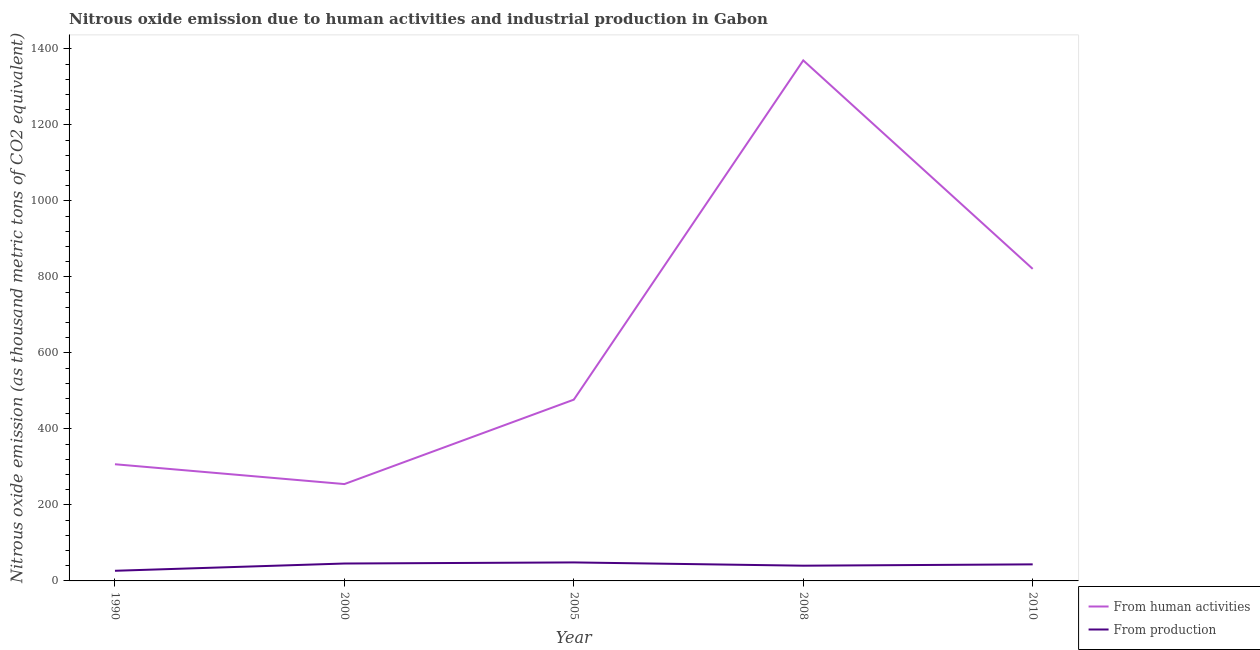How many different coloured lines are there?
Your answer should be compact. 2. Does the line corresponding to amount of emissions generated from industries intersect with the line corresponding to amount of emissions from human activities?
Provide a succinct answer. No. What is the amount of emissions from human activities in 2000?
Offer a very short reply. 254.9. Across all years, what is the maximum amount of emissions generated from industries?
Your answer should be very brief. 48.7. Across all years, what is the minimum amount of emissions generated from industries?
Your answer should be compact. 26.7. In which year was the amount of emissions generated from industries maximum?
Ensure brevity in your answer.  2005. What is the total amount of emissions generated from industries in the graph?
Offer a very short reply. 204.9. What is the difference between the amount of emissions generated from industries in 2005 and that in 2008?
Your answer should be very brief. 8.6. What is the difference between the amount of emissions from human activities in 2005 and the amount of emissions generated from industries in 1990?
Ensure brevity in your answer.  450.4. What is the average amount of emissions from human activities per year?
Ensure brevity in your answer.  646.08. In the year 2000, what is the difference between the amount of emissions from human activities and amount of emissions generated from industries?
Provide a short and direct response. 209.1. What is the ratio of the amount of emissions generated from industries in 2005 to that in 2010?
Make the answer very short. 1.12. What is the difference between the highest and the second highest amount of emissions from human activities?
Keep it short and to the point. 548.7. What is the difference between the highest and the lowest amount of emissions generated from industries?
Your answer should be very brief. 22. Does the amount of emissions generated from industries monotonically increase over the years?
Ensure brevity in your answer.  No. How many lines are there?
Offer a terse response. 2. What is the difference between two consecutive major ticks on the Y-axis?
Keep it short and to the point. 200. How many legend labels are there?
Your answer should be very brief. 2. How are the legend labels stacked?
Your answer should be compact. Vertical. What is the title of the graph?
Ensure brevity in your answer.  Nitrous oxide emission due to human activities and industrial production in Gabon. What is the label or title of the Y-axis?
Provide a succinct answer. Nitrous oxide emission (as thousand metric tons of CO2 equivalent). What is the Nitrous oxide emission (as thousand metric tons of CO2 equivalent) in From human activities in 1990?
Your answer should be very brief. 307.1. What is the Nitrous oxide emission (as thousand metric tons of CO2 equivalent) in From production in 1990?
Your response must be concise. 26.7. What is the Nitrous oxide emission (as thousand metric tons of CO2 equivalent) of From human activities in 2000?
Offer a very short reply. 254.9. What is the Nitrous oxide emission (as thousand metric tons of CO2 equivalent) in From production in 2000?
Offer a very short reply. 45.8. What is the Nitrous oxide emission (as thousand metric tons of CO2 equivalent) in From human activities in 2005?
Provide a short and direct response. 477.1. What is the Nitrous oxide emission (as thousand metric tons of CO2 equivalent) of From production in 2005?
Your response must be concise. 48.7. What is the Nitrous oxide emission (as thousand metric tons of CO2 equivalent) of From human activities in 2008?
Keep it short and to the point. 1370. What is the Nitrous oxide emission (as thousand metric tons of CO2 equivalent) in From production in 2008?
Keep it short and to the point. 40.1. What is the Nitrous oxide emission (as thousand metric tons of CO2 equivalent) of From human activities in 2010?
Your answer should be very brief. 821.3. What is the Nitrous oxide emission (as thousand metric tons of CO2 equivalent) of From production in 2010?
Your answer should be very brief. 43.6. Across all years, what is the maximum Nitrous oxide emission (as thousand metric tons of CO2 equivalent) in From human activities?
Provide a succinct answer. 1370. Across all years, what is the maximum Nitrous oxide emission (as thousand metric tons of CO2 equivalent) of From production?
Provide a succinct answer. 48.7. Across all years, what is the minimum Nitrous oxide emission (as thousand metric tons of CO2 equivalent) in From human activities?
Keep it short and to the point. 254.9. Across all years, what is the minimum Nitrous oxide emission (as thousand metric tons of CO2 equivalent) of From production?
Ensure brevity in your answer.  26.7. What is the total Nitrous oxide emission (as thousand metric tons of CO2 equivalent) in From human activities in the graph?
Make the answer very short. 3230.4. What is the total Nitrous oxide emission (as thousand metric tons of CO2 equivalent) in From production in the graph?
Offer a very short reply. 204.9. What is the difference between the Nitrous oxide emission (as thousand metric tons of CO2 equivalent) in From human activities in 1990 and that in 2000?
Provide a short and direct response. 52.2. What is the difference between the Nitrous oxide emission (as thousand metric tons of CO2 equivalent) in From production in 1990 and that in 2000?
Offer a very short reply. -19.1. What is the difference between the Nitrous oxide emission (as thousand metric tons of CO2 equivalent) of From human activities in 1990 and that in 2005?
Your response must be concise. -170. What is the difference between the Nitrous oxide emission (as thousand metric tons of CO2 equivalent) of From human activities in 1990 and that in 2008?
Keep it short and to the point. -1062.9. What is the difference between the Nitrous oxide emission (as thousand metric tons of CO2 equivalent) in From human activities in 1990 and that in 2010?
Keep it short and to the point. -514.2. What is the difference between the Nitrous oxide emission (as thousand metric tons of CO2 equivalent) in From production in 1990 and that in 2010?
Keep it short and to the point. -16.9. What is the difference between the Nitrous oxide emission (as thousand metric tons of CO2 equivalent) of From human activities in 2000 and that in 2005?
Offer a very short reply. -222.2. What is the difference between the Nitrous oxide emission (as thousand metric tons of CO2 equivalent) of From production in 2000 and that in 2005?
Keep it short and to the point. -2.9. What is the difference between the Nitrous oxide emission (as thousand metric tons of CO2 equivalent) of From human activities in 2000 and that in 2008?
Offer a terse response. -1115.1. What is the difference between the Nitrous oxide emission (as thousand metric tons of CO2 equivalent) of From human activities in 2000 and that in 2010?
Ensure brevity in your answer.  -566.4. What is the difference between the Nitrous oxide emission (as thousand metric tons of CO2 equivalent) of From human activities in 2005 and that in 2008?
Keep it short and to the point. -892.9. What is the difference between the Nitrous oxide emission (as thousand metric tons of CO2 equivalent) of From production in 2005 and that in 2008?
Provide a succinct answer. 8.6. What is the difference between the Nitrous oxide emission (as thousand metric tons of CO2 equivalent) in From human activities in 2005 and that in 2010?
Keep it short and to the point. -344.2. What is the difference between the Nitrous oxide emission (as thousand metric tons of CO2 equivalent) in From production in 2005 and that in 2010?
Give a very brief answer. 5.1. What is the difference between the Nitrous oxide emission (as thousand metric tons of CO2 equivalent) in From human activities in 2008 and that in 2010?
Provide a short and direct response. 548.7. What is the difference between the Nitrous oxide emission (as thousand metric tons of CO2 equivalent) in From human activities in 1990 and the Nitrous oxide emission (as thousand metric tons of CO2 equivalent) in From production in 2000?
Provide a succinct answer. 261.3. What is the difference between the Nitrous oxide emission (as thousand metric tons of CO2 equivalent) in From human activities in 1990 and the Nitrous oxide emission (as thousand metric tons of CO2 equivalent) in From production in 2005?
Provide a short and direct response. 258.4. What is the difference between the Nitrous oxide emission (as thousand metric tons of CO2 equivalent) of From human activities in 1990 and the Nitrous oxide emission (as thousand metric tons of CO2 equivalent) of From production in 2008?
Provide a short and direct response. 267. What is the difference between the Nitrous oxide emission (as thousand metric tons of CO2 equivalent) of From human activities in 1990 and the Nitrous oxide emission (as thousand metric tons of CO2 equivalent) of From production in 2010?
Give a very brief answer. 263.5. What is the difference between the Nitrous oxide emission (as thousand metric tons of CO2 equivalent) of From human activities in 2000 and the Nitrous oxide emission (as thousand metric tons of CO2 equivalent) of From production in 2005?
Offer a very short reply. 206.2. What is the difference between the Nitrous oxide emission (as thousand metric tons of CO2 equivalent) in From human activities in 2000 and the Nitrous oxide emission (as thousand metric tons of CO2 equivalent) in From production in 2008?
Your answer should be very brief. 214.8. What is the difference between the Nitrous oxide emission (as thousand metric tons of CO2 equivalent) in From human activities in 2000 and the Nitrous oxide emission (as thousand metric tons of CO2 equivalent) in From production in 2010?
Keep it short and to the point. 211.3. What is the difference between the Nitrous oxide emission (as thousand metric tons of CO2 equivalent) in From human activities in 2005 and the Nitrous oxide emission (as thousand metric tons of CO2 equivalent) in From production in 2008?
Keep it short and to the point. 437. What is the difference between the Nitrous oxide emission (as thousand metric tons of CO2 equivalent) of From human activities in 2005 and the Nitrous oxide emission (as thousand metric tons of CO2 equivalent) of From production in 2010?
Make the answer very short. 433.5. What is the difference between the Nitrous oxide emission (as thousand metric tons of CO2 equivalent) in From human activities in 2008 and the Nitrous oxide emission (as thousand metric tons of CO2 equivalent) in From production in 2010?
Make the answer very short. 1326.4. What is the average Nitrous oxide emission (as thousand metric tons of CO2 equivalent) of From human activities per year?
Your answer should be compact. 646.08. What is the average Nitrous oxide emission (as thousand metric tons of CO2 equivalent) in From production per year?
Provide a succinct answer. 40.98. In the year 1990, what is the difference between the Nitrous oxide emission (as thousand metric tons of CO2 equivalent) of From human activities and Nitrous oxide emission (as thousand metric tons of CO2 equivalent) of From production?
Offer a terse response. 280.4. In the year 2000, what is the difference between the Nitrous oxide emission (as thousand metric tons of CO2 equivalent) in From human activities and Nitrous oxide emission (as thousand metric tons of CO2 equivalent) in From production?
Offer a terse response. 209.1. In the year 2005, what is the difference between the Nitrous oxide emission (as thousand metric tons of CO2 equivalent) of From human activities and Nitrous oxide emission (as thousand metric tons of CO2 equivalent) of From production?
Your answer should be very brief. 428.4. In the year 2008, what is the difference between the Nitrous oxide emission (as thousand metric tons of CO2 equivalent) in From human activities and Nitrous oxide emission (as thousand metric tons of CO2 equivalent) in From production?
Offer a very short reply. 1329.9. In the year 2010, what is the difference between the Nitrous oxide emission (as thousand metric tons of CO2 equivalent) of From human activities and Nitrous oxide emission (as thousand metric tons of CO2 equivalent) of From production?
Keep it short and to the point. 777.7. What is the ratio of the Nitrous oxide emission (as thousand metric tons of CO2 equivalent) in From human activities in 1990 to that in 2000?
Provide a short and direct response. 1.2. What is the ratio of the Nitrous oxide emission (as thousand metric tons of CO2 equivalent) in From production in 1990 to that in 2000?
Offer a terse response. 0.58. What is the ratio of the Nitrous oxide emission (as thousand metric tons of CO2 equivalent) in From human activities in 1990 to that in 2005?
Provide a short and direct response. 0.64. What is the ratio of the Nitrous oxide emission (as thousand metric tons of CO2 equivalent) in From production in 1990 to that in 2005?
Your response must be concise. 0.55. What is the ratio of the Nitrous oxide emission (as thousand metric tons of CO2 equivalent) of From human activities in 1990 to that in 2008?
Offer a terse response. 0.22. What is the ratio of the Nitrous oxide emission (as thousand metric tons of CO2 equivalent) in From production in 1990 to that in 2008?
Ensure brevity in your answer.  0.67. What is the ratio of the Nitrous oxide emission (as thousand metric tons of CO2 equivalent) of From human activities in 1990 to that in 2010?
Make the answer very short. 0.37. What is the ratio of the Nitrous oxide emission (as thousand metric tons of CO2 equivalent) in From production in 1990 to that in 2010?
Make the answer very short. 0.61. What is the ratio of the Nitrous oxide emission (as thousand metric tons of CO2 equivalent) in From human activities in 2000 to that in 2005?
Provide a short and direct response. 0.53. What is the ratio of the Nitrous oxide emission (as thousand metric tons of CO2 equivalent) of From production in 2000 to that in 2005?
Ensure brevity in your answer.  0.94. What is the ratio of the Nitrous oxide emission (as thousand metric tons of CO2 equivalent) of From human activities in 2000 to that in 2008?
Provide a succinct answer. 0.19. What is the ratio of the Nitrous oxide emission (as thousand metric tons of CO2 equivalent) in From production in 2000 to that in 2008?
Offer a very short reply. 1.14. What is the ratio of the Nitrous oxide emission (as thousand metric tons of CO2 equivalent) in From human activities in 2000 to that in 2010?
Your answer should be very brief. 0.31. What is the ratio of the Nitrous oxide emission (as thousand metric tons of CO2 equivalent) of From production in 2000 to that in 2010?
Your answer should be compact. 1.05. What is the ratio of the Nitrous oxide emission (as thousand metric tons of CO2 equivalent) in From human activities in 2005 to that in 2008?
Make the answer very short. 0.35. What is the ratio of the Nitrous oxide emission (as thousand metric tons of CO2 equivalent) of From production in 2005 to that in 2008?
Keep it short and to the point. 1.21. What is the ratio of the Nitrous oxide emission (as thousand metric tons of CO2 equivalent) in From human activities in 2005 to that in 2010?
Offer a terse response. 0.58. What is the ratio of the Nitrous oxide emission (as thousand metric tons of CO2 equivalent) of From production in 2005 to that in 2010?
Ensure brevity in your answer.  1.12. What is the ratio of the Nitrous oxide emission (as thousand metric tons of CO2 equivalent) in From human activities in 2008 to that in 2010?
Your response must be concise. 1.67. What is the ratio of the Nitrous oxide emission (as thousand metric tons of CO2 equivalent) in From production in 2008 to that in 2010?
Your response must be concise. 0.92. What is the difference between the highest and the second highest Nitrous oxide emission (as thousand metric tons of CO2 equivalent) in From human activities?
Your response must be concise. 548.7. What is the difference between the highest and the lowest Nitrous oxide emission (as thousand metric tons of CO2 equivalent) in From human activities?
Offer a very short reply. 1115.1. 